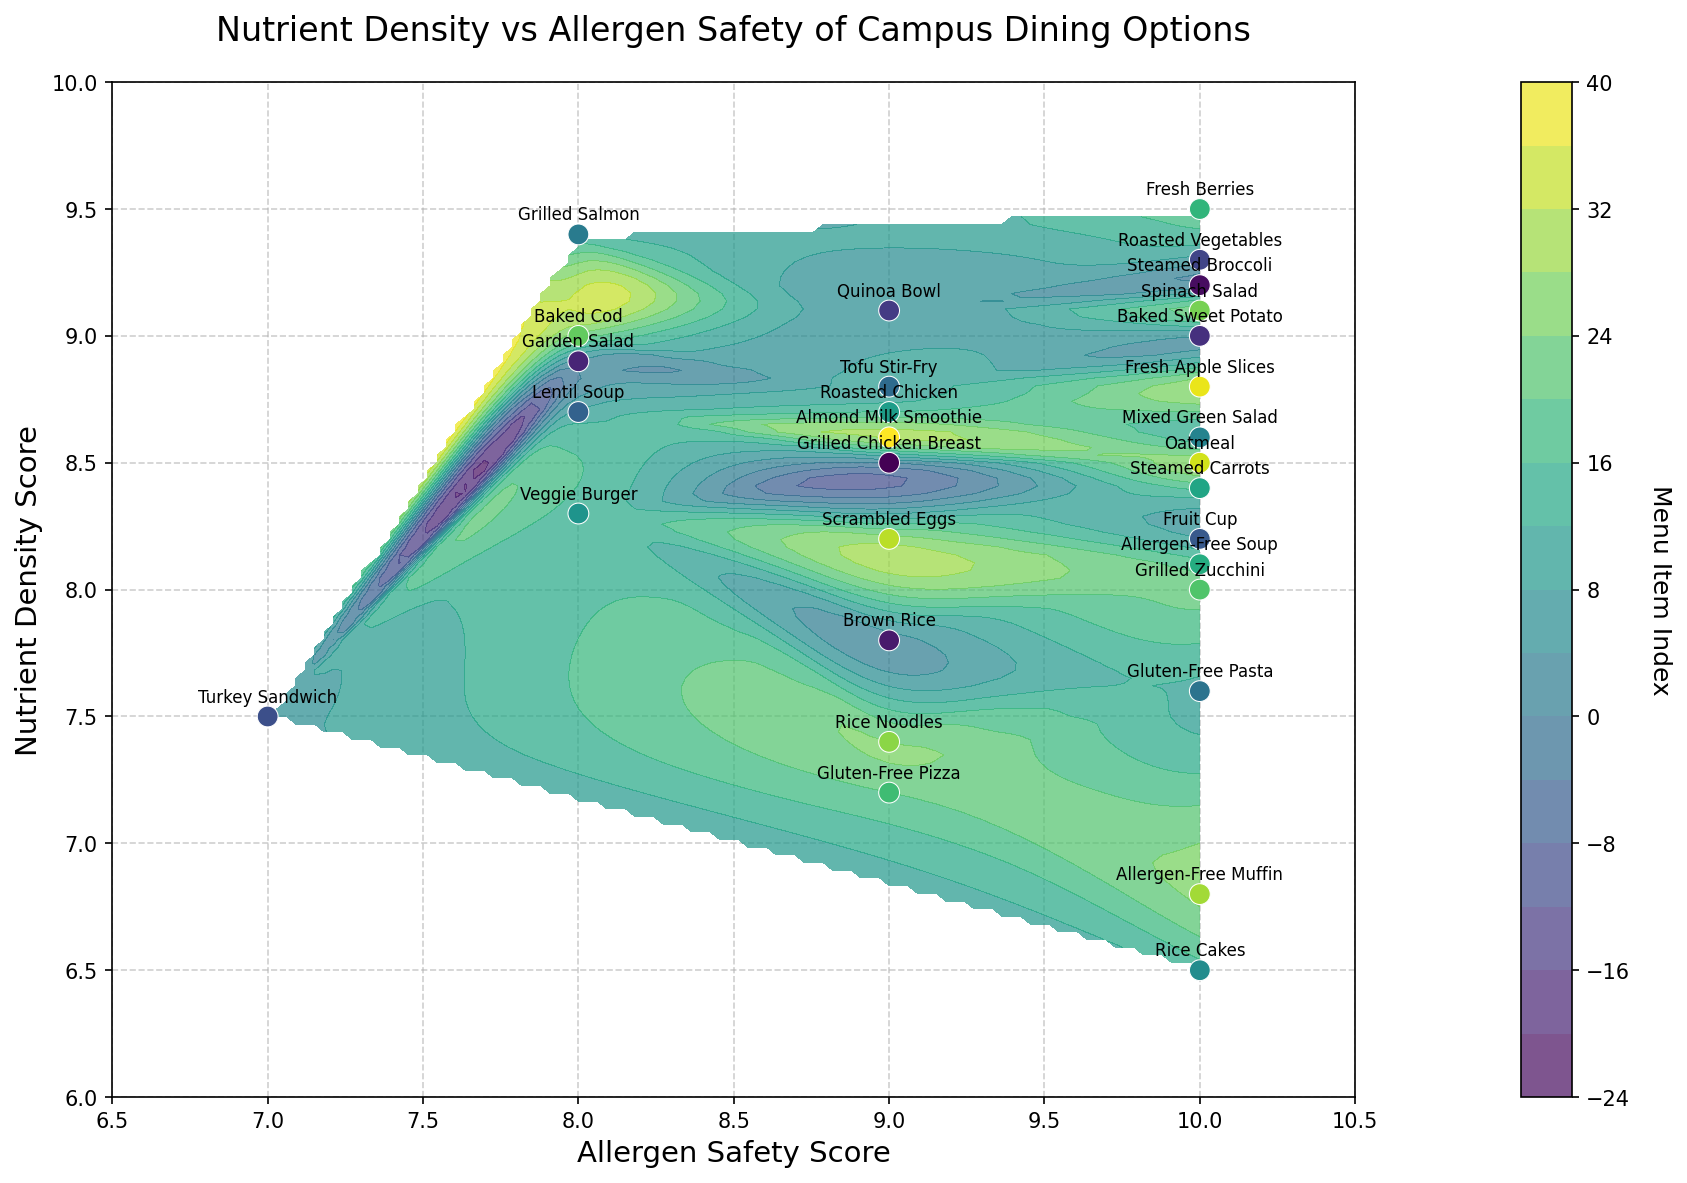Which dining hall has the food item with the highest nutrient density score? Locate the highest point on the y-axis which represents the nutrient density score and check the corresponding menu item. Identify the dining hall for this item.
Answer: East Commons Which item in the Main Hall has the highest allergen safety score? Identify the marker positions for Main Hall items and check the scores on the x-axis. The one with the highest x-value is the item with the highest allergen safety score.
Answer: Steamed Broccoli and Baked Sweet Potato (both score 10) Do the allergens-safe items tend to have a higher or lower nutrient density score? Analyze the general trend of the marker positions on the plot. Observe whether most items with high allergen safety scores (high x-values) are associated with high or low y-values (nutrient density scores).
Answer: Higher Which dining hall has the most items with allergen safety scores of 10? Check marker positions with an x-value of 10 and count which dining hall these items belong to.
Answer: East Commons Between South Hall and Student Center, which hall has the item with the lowest nutrient density score? Look at the marker positions for South Hall and Student Center and identify the one with the lowest y-value among them.
Answer: South Hall What is the overall trend of nutrient density concerning allergen safety scores? Examine the general pattern of markers across the plot to determine if there's a visible trend, such as whether higher allergen safety scores correspond with higher or lower nutrient density scores.
Answer: Positive correlation What is the difference in nutrient density scores between the highest and lowest scoring items in West Campus? Identify the highest and lowest y-values for items in West Campus and calculate the difference between these scores.
Answer: 2.9 (9.4 - 6.5) Contrast the nutrient density of the Grilled Salmon at West Campus with the Brown Rice at Main Hall. Which one is higher? Find the nutrient density scores for Grilled Salmon (y = 9.4) and Brown Rice (y = 7.8). Compare the two values.
Answer: Grilled Salmon Is there a dining hall that has all items with nutrient density scores above 8? Evaluate each dining hall’s items and check if all their nutrient density scores exceed 8.
Answer: No 